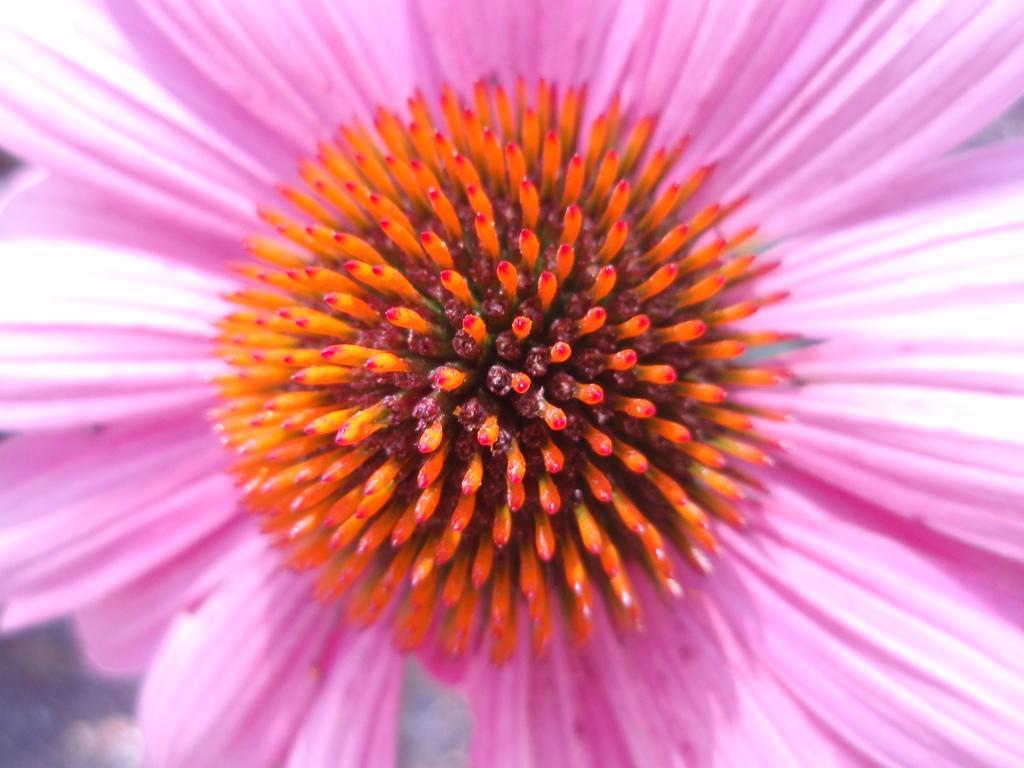Describe this image in one or two sentences. In this picture we can see a flower with pink petals and at the center, we have red yellow colored pistils. 